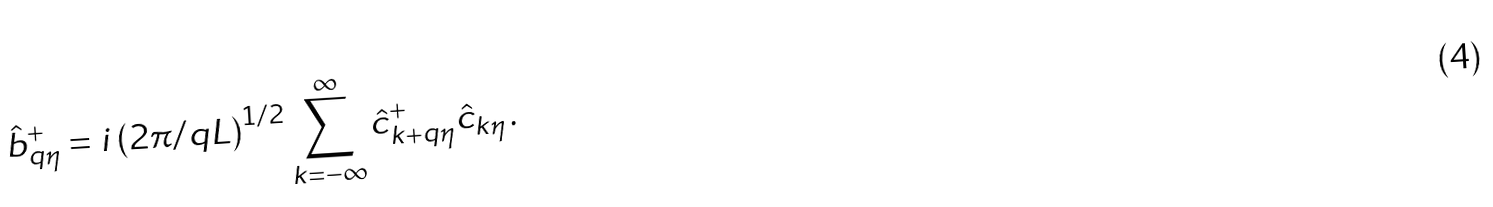Convert formula to latex. <formula><loc_0><loc_0><loc_500><loc_500>\hat { b } _ { q \eta } ^ { + } = i \left ( 2 \pi / q L \right ) ^ { 1 / 2 } \sum _ { k = - \infty } ^ { \infty } \hat { c } _ { k + q \eta } ^ { + } \hat { c } _ { k \eta } \, .</formula> 